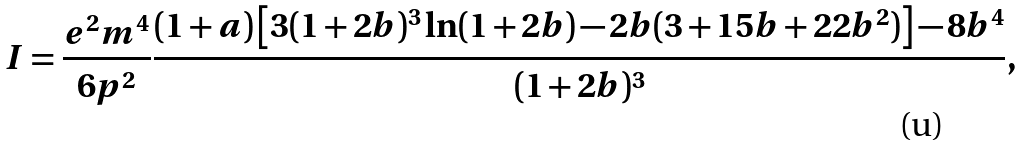Convert formula to latex. <formula><loc_0><loc_0><loc_500><loc_500>I = \frac { e ^ { 2 } m ^ { 4 } } { 6 p ^ { 2 } } \frac { ( 1 + a ) \left [ 3 ( 1 + 2 b ) ^ { 3 } \ln ( 1 + 2 b ) - 2 b ( 3 + 1 5 b + 2 2 b ^ { 2 } ) \right ] - 8 b ^ { 4 } } { ( 1 + 2 b ) ^ { 3 } } ,</formula> 